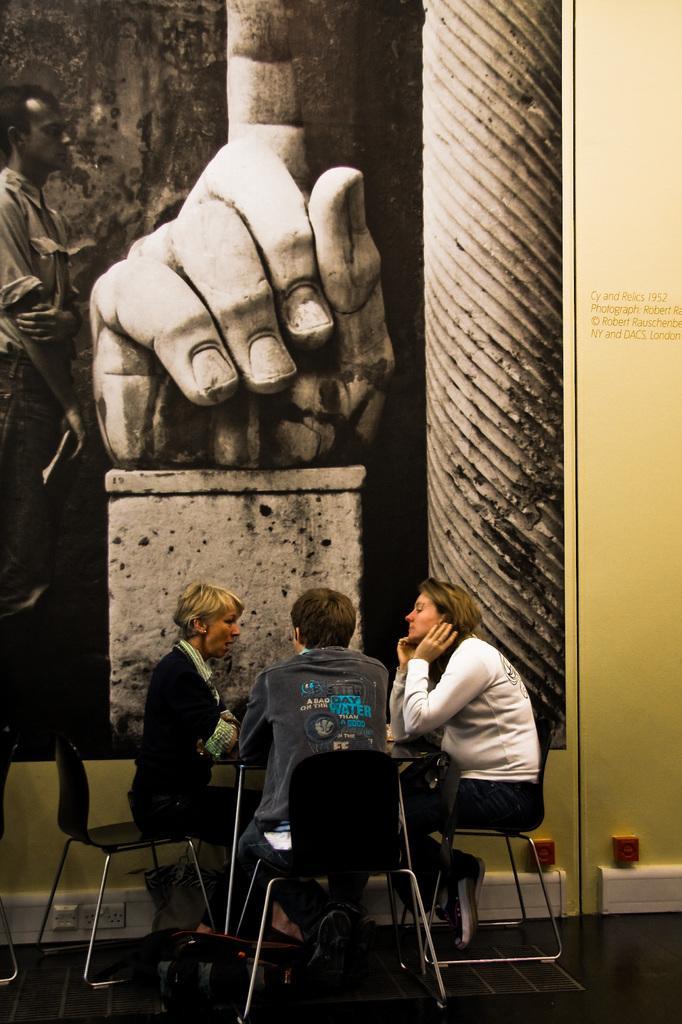Can you describe this image briefly? There are three persons sitting in a chair and there is a table in front of them. 